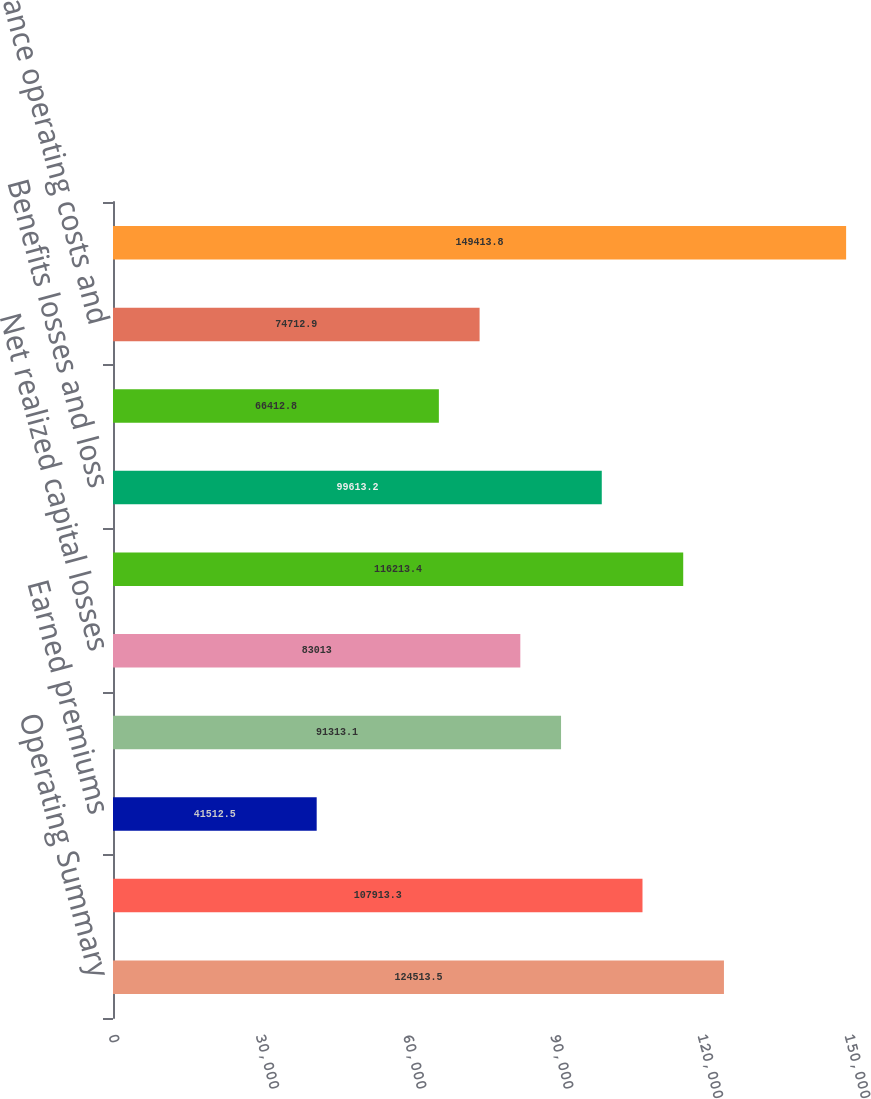Convert chart. <chart><loc_0><loc_0><loc_500><loc_500><bar_chart><fcel>Operating Summary<fcel>Fee income and other<fcel>Earned premiums<fcel>Net investment income<fcel>Net realized capital losses<fcel>Total revenues<fcel>Benefits losses and loss<fcel>Amortization of DAC<fcel>Insurance operating costs and<fcel>Total benefits losses and<nl><fcel>124514<fcel>107913<fcel>41512.5<fcel>91313.1<fcel>83013<fcel>116213<fcel>99613.2<fcel>66412.8<fcel>74712.9<fcel>149414<nl></chart> 